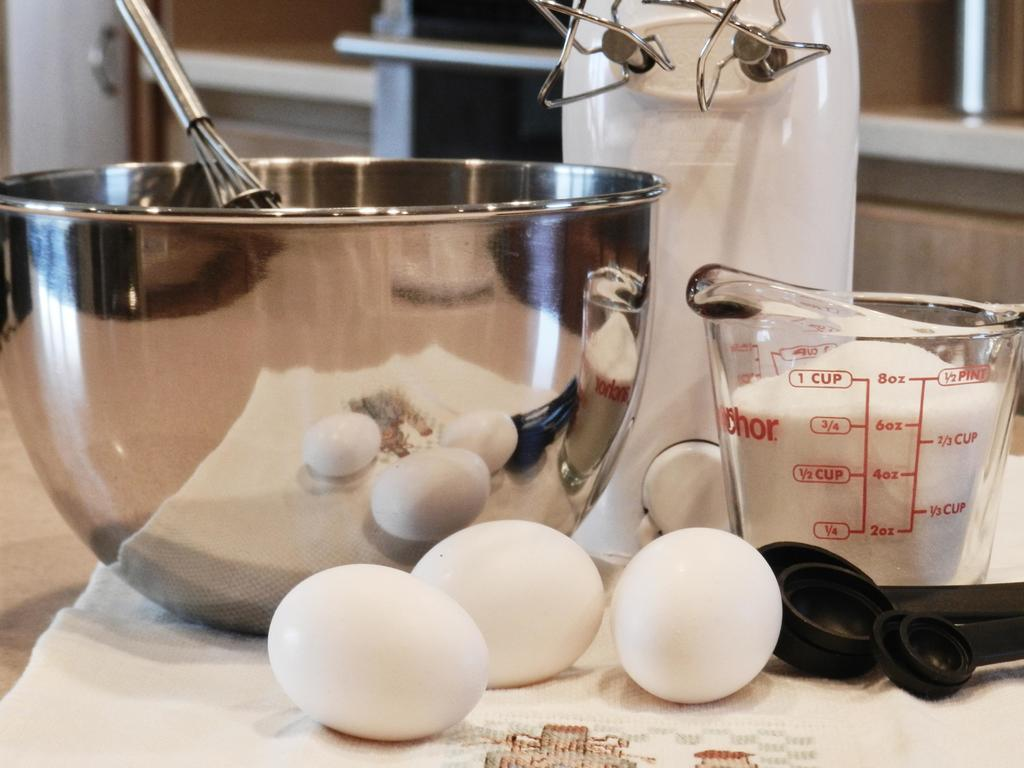<image>
Summarize the visual content of the image. 6 oz of ingredients are in a jug on a kitchen surface. 